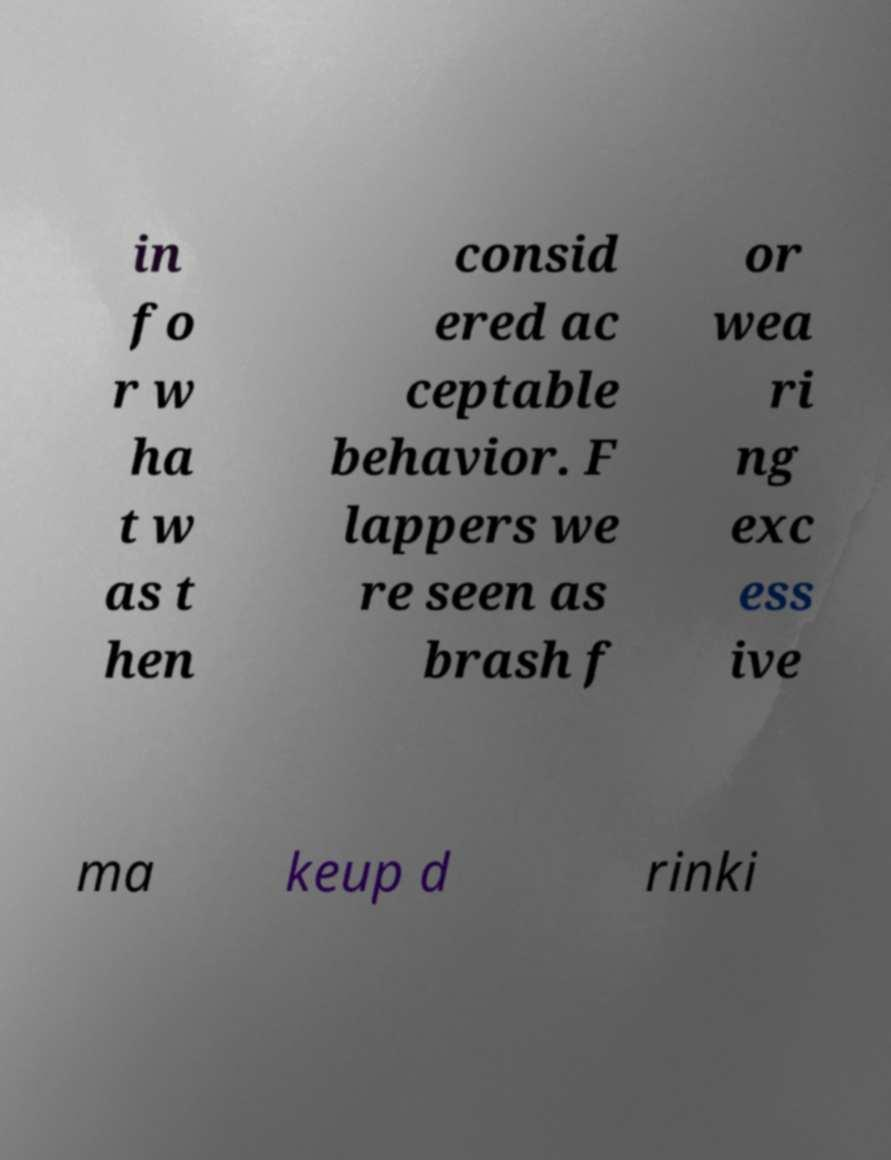I need the written content from this picture converted into text. Can you do that? in fo r w ha t w as t hen consid ered ac ceptable behavior. F lappers we re seen as brash f or wea ri ng exc ess ive ma keup d rinki 